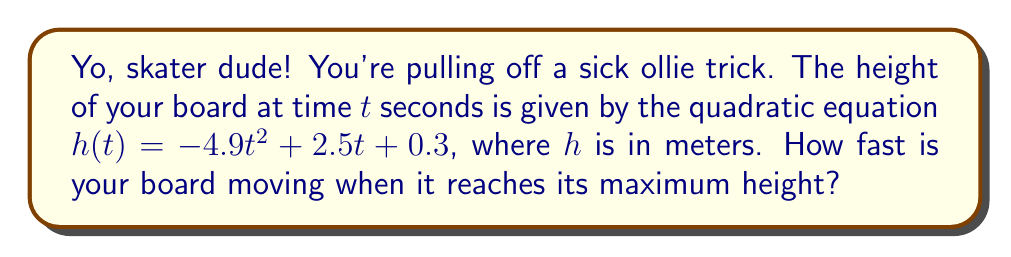Can you answer this question? Alright, let's break this down:

1) The quadratic equation for the height is:
   $$h(t) = -4.9t^2 + 2.5t + 0.3$$

2) To find when the board reaches its maximum height, we need to find the vertex of this parabola. The t-coordinate of the vertex gives us the time when the board is at its highest point.

3) For a quadratic equation in the form $ax^2 + bx + c$, the t-coordinate of the vertex is given by $t = -\frac{b}{2a}$

4) In our equation, $a = -4.9$ and $b = 2.5$. So:
   $$t = -\frac{2.5}{2(-4.9)} = \frac{2.5}{9.8} \approx 0.255 \text{ seconds}$$

5) Now, to find the speed at this point, we need to find the derivative of $h(t)$ and evaluate it at $t = 0.255$

6) The derivative of $h(t)$ is:
   $$h'(t) = -9.8t + 2.5$$

7) This gives us the velocity function. Plugging in $t = 0.255$:
   $$h'(0.255) = -9.8(0.255) + 2.5 = 0$$

8) The speed at the highest point is 0 m/s, which makes sense because at the top of any projectile motion, there's a brief moment where the object stops before falling back down.
Answer: The speed of the skateboard when it reaches its maximum height is 0 m/s. 